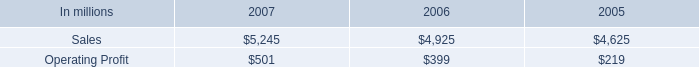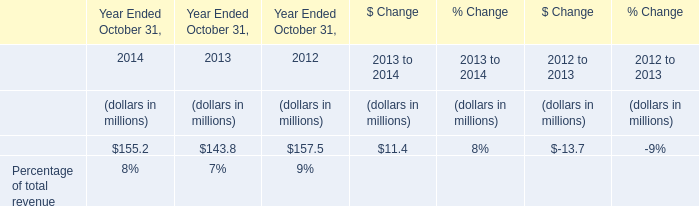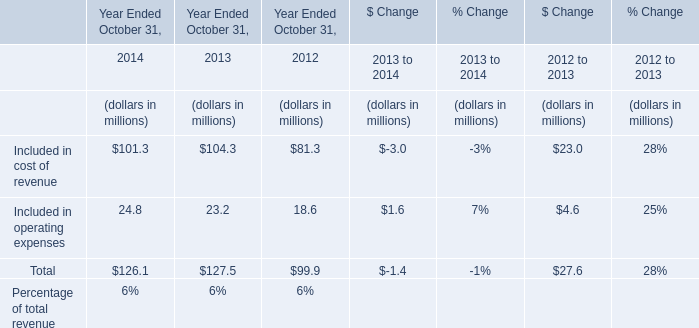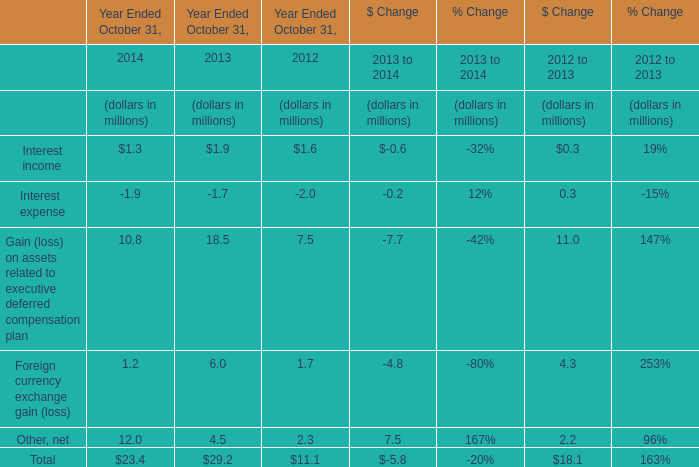What's the current growth rate of Included in operating expenses? 
Computations: ((24.8 - 23.2) / 23.2)
Answer: 0.06897. 